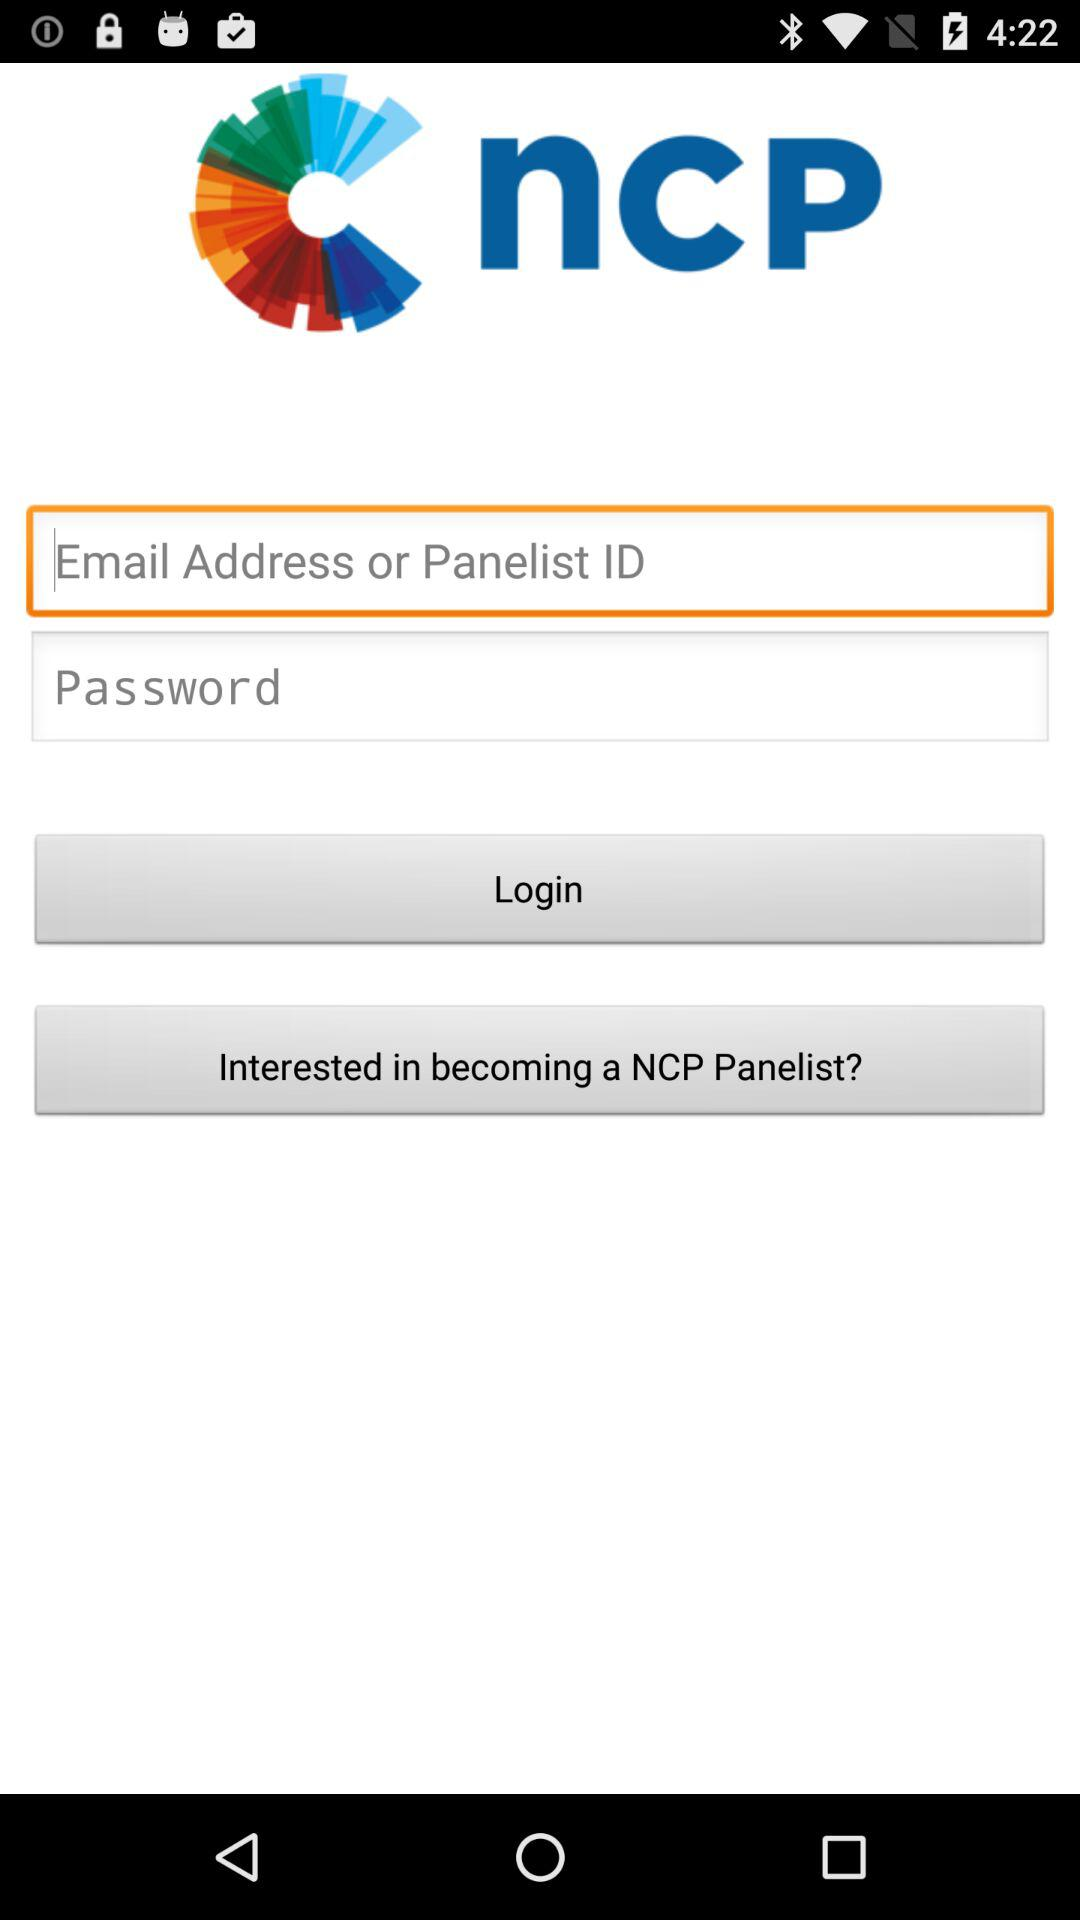What is the name of the application? The name of the application is "ncP". 